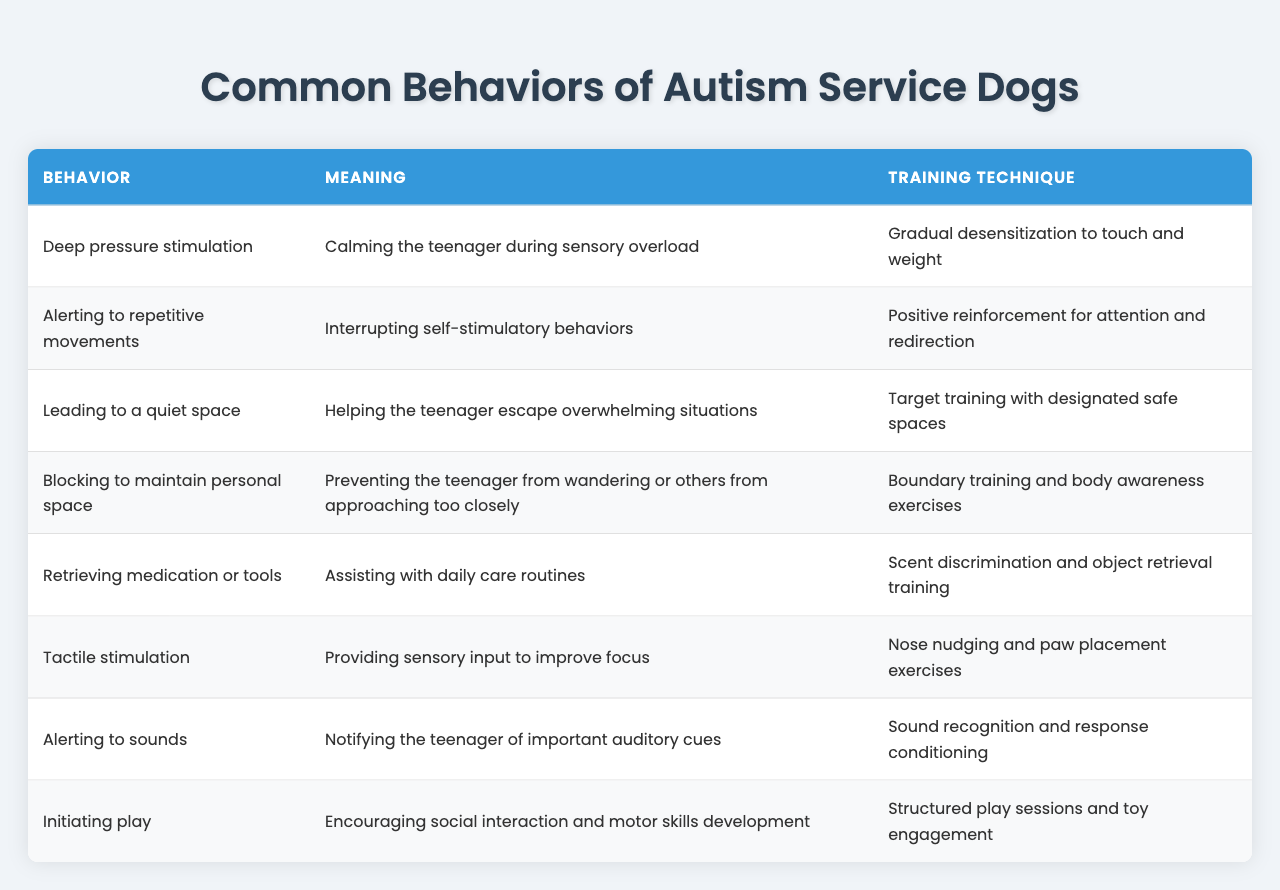What behavior is used for calming a teenager during sensory overload? The table lists "Deep pressure stimulation" as the behavior for calming a teenager during sensory overload.
Answer: Deep pressure stimulation What is the meaning of the behavior that involves alerting to repetitive movements? According to the table, alerting to repetitive movements means interrupting self-stimulatory behaviors.
Answer: Interrupting self-stimulatory behaviors Which training technique is used for leading a teenager to a quiet space? The table states that "Target training with designated safe spaces" is the training technique used to lead a teenager to a quiet space.
Answer: Target training with designated safe spaces How many behaviors are mentioned in the table? The table lists a total of eight distinct behaviors exhibited by autism service dogs.
Answer: Eight What behavior assists with daily care routines? The table identifies "Retrieving medication or tools" as the behavior that assists with daily care routines.
Answer: Retrieving medication or tools Is tactile stimulation meant to improve focus? Yes, the table indicates that tactile stimulation provides sensory input to improve focus.
Answer: Yes Which behavior involves preventing the teenager from wandering? The table points out that "Blocking to maintain personal space" is the behavior that prevents the teenager from wandering.
Answer: Blocking to maintain personal space What two behaviors help with social interaction according to the table? The table shows that "Initiating play" and "Alerting to sounds" are the two behaviors that contribute to social interaction.
Answer: Initiating play and Alerting to sounds If a dog alerts to sounds, what is its meaning? The table explains that alerting to sounds notifies the teenager of important auditory cues.
Answer: Notifying of important auditory cues Can you list the training technique for tactile stimulation? The training technique for tactile stimulation, as noted in the table, is "Nose nudging and paw placement exercises."
Answer: Nose nudging and paw placement exercises 